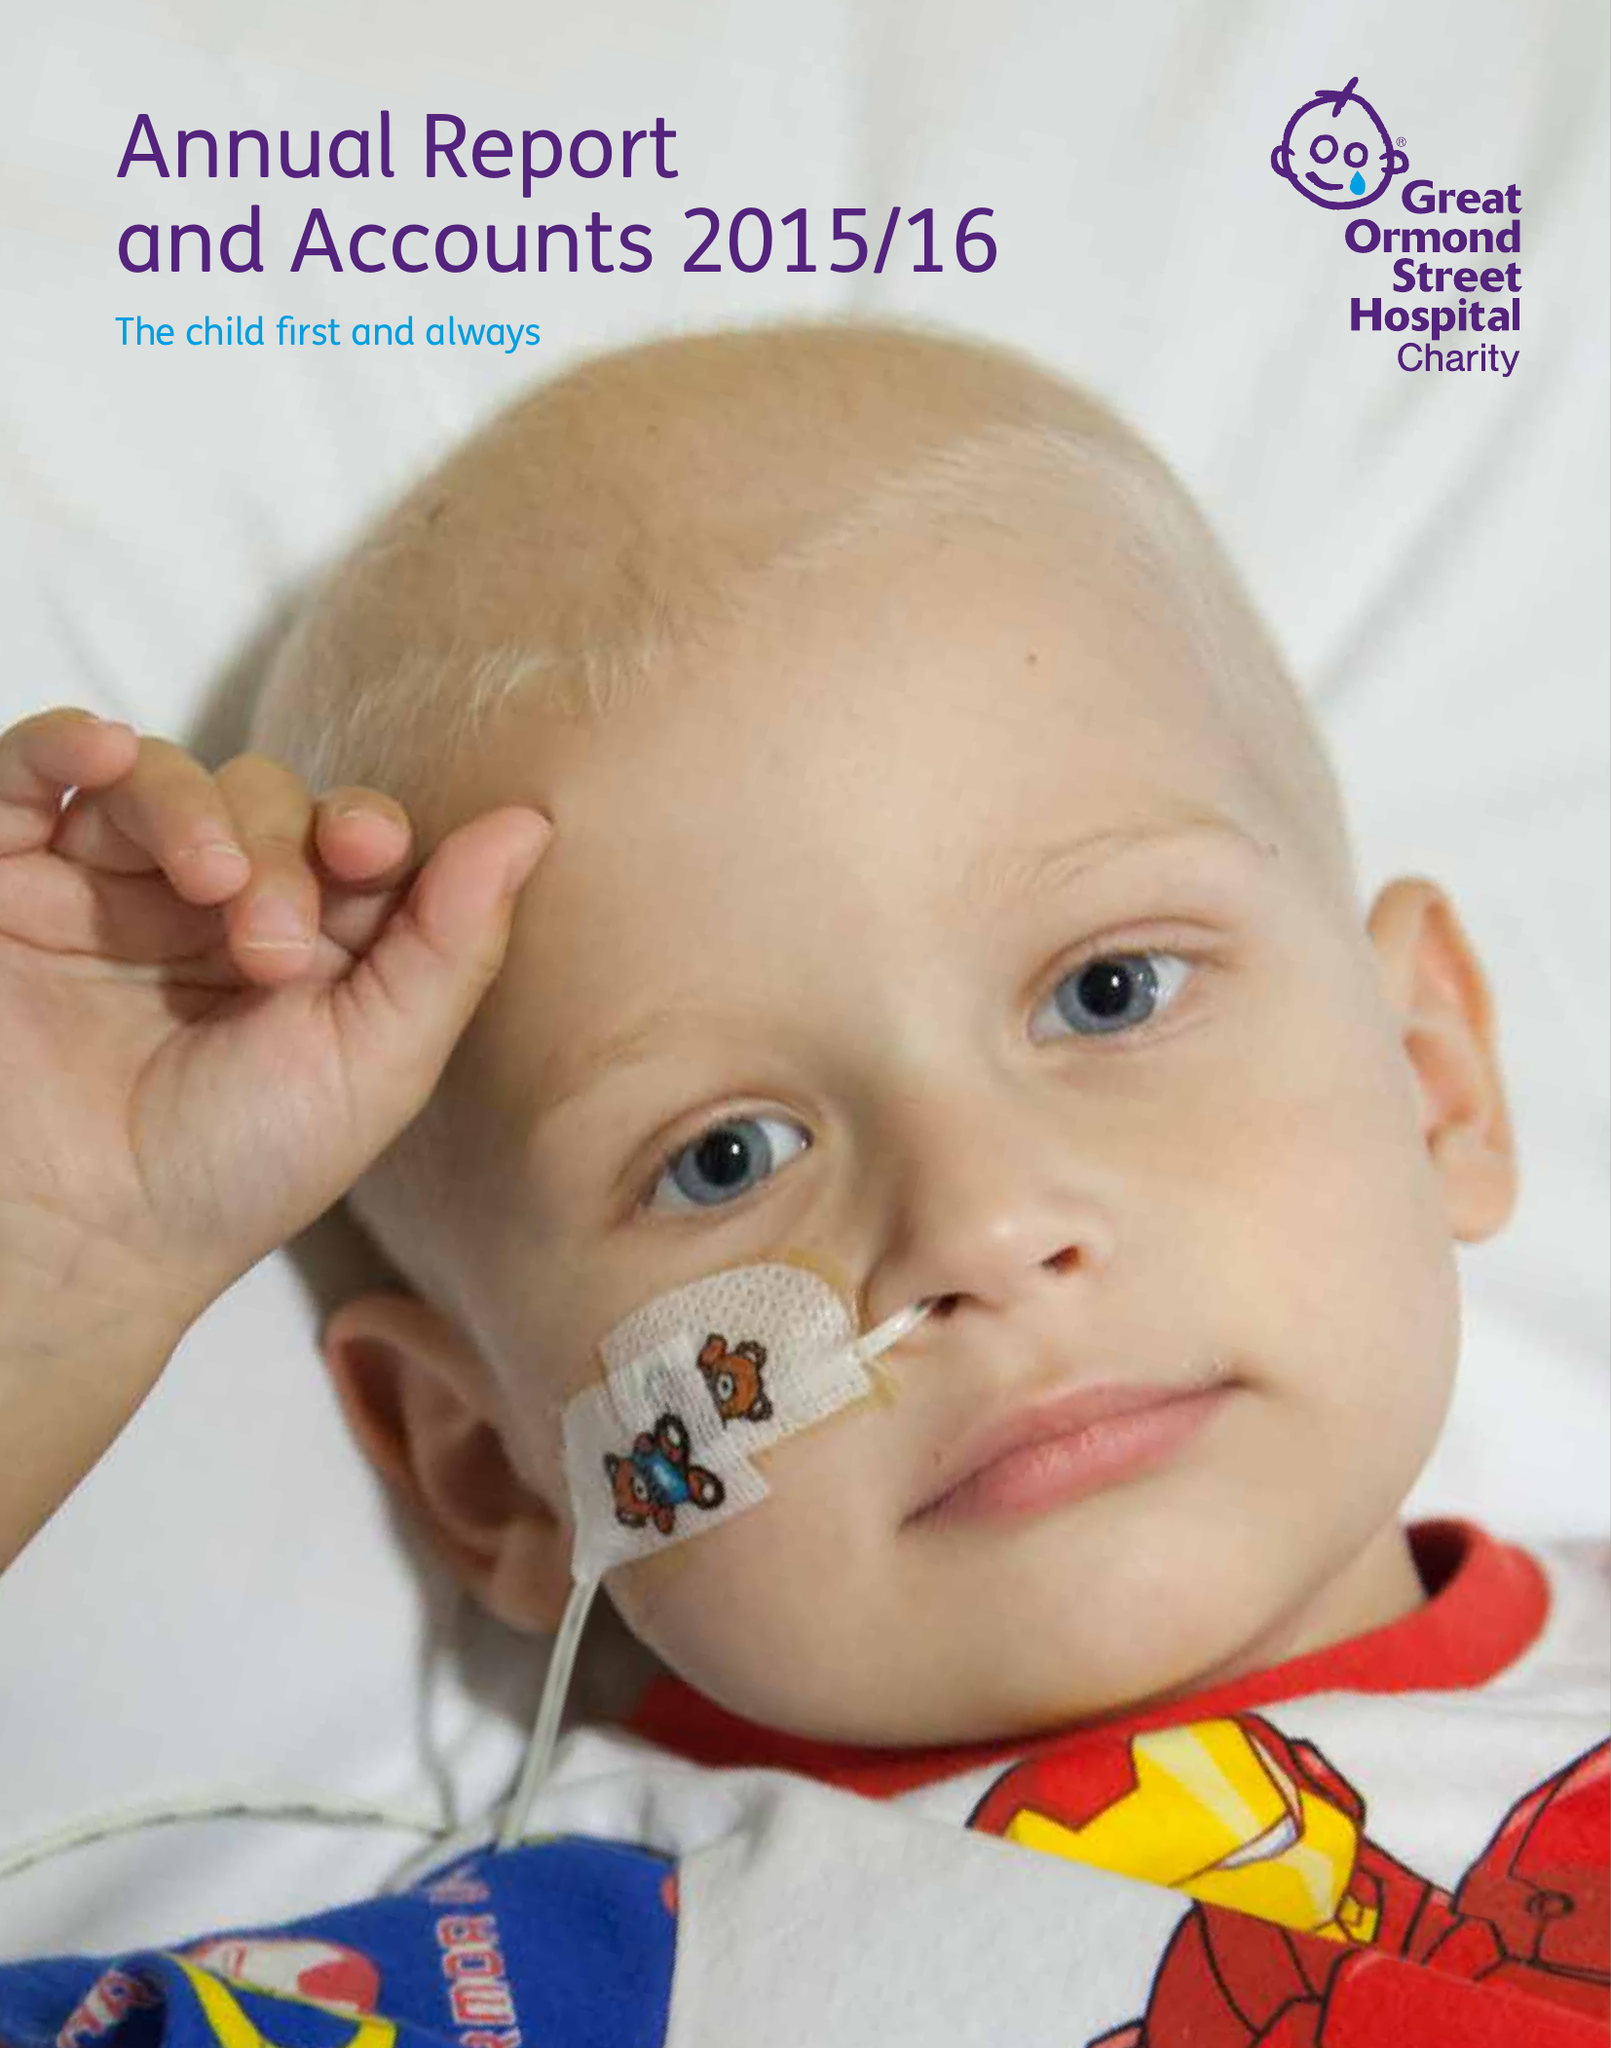What is the value for the report_date?
Answer the question using a single word or phrase. 2016-03-31 